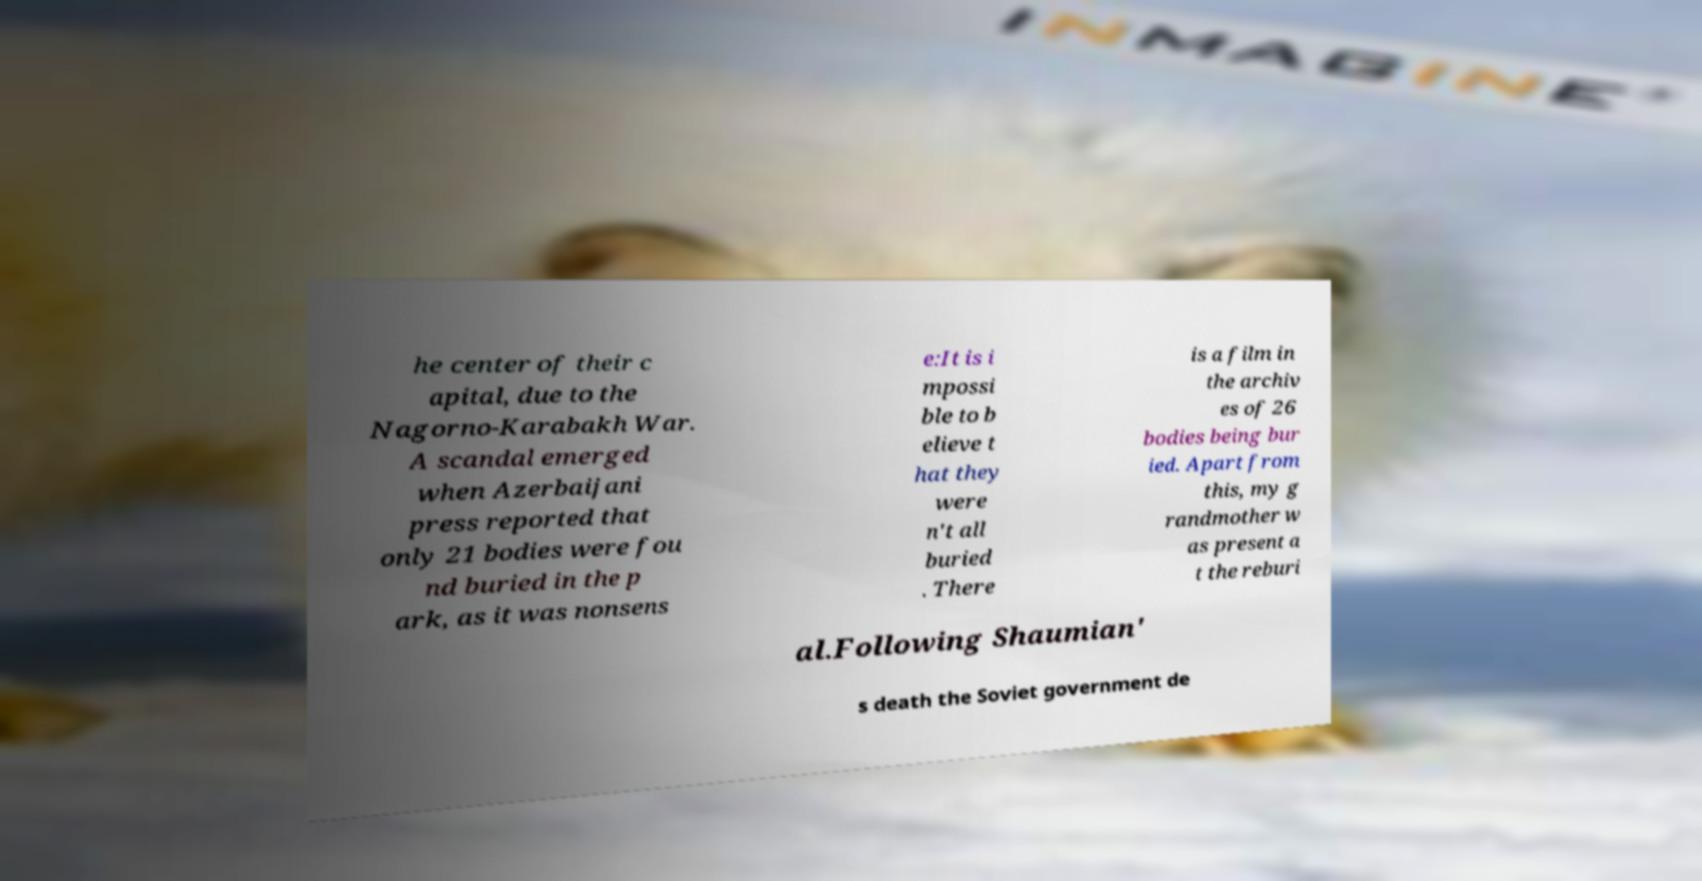Can you read and provide the text displayed in the image?This photo seems to have some interesting text. Can you extract and type it out for me? he center of their c apital, due to the Nagorno-Karabakh War. A scandal emerged when Azerbaijani press reported that only 21 bodies were fou nd buried in the p ark, as it was nonsens e:It is i mpossi ble to b elieve t hat they were n't all buried . There is a film in the archiv es of 26 bodies being bur ied. Apart from this, my g randmother w as present a t the reburi al.Following Shaumian' s death the Soviet government de 